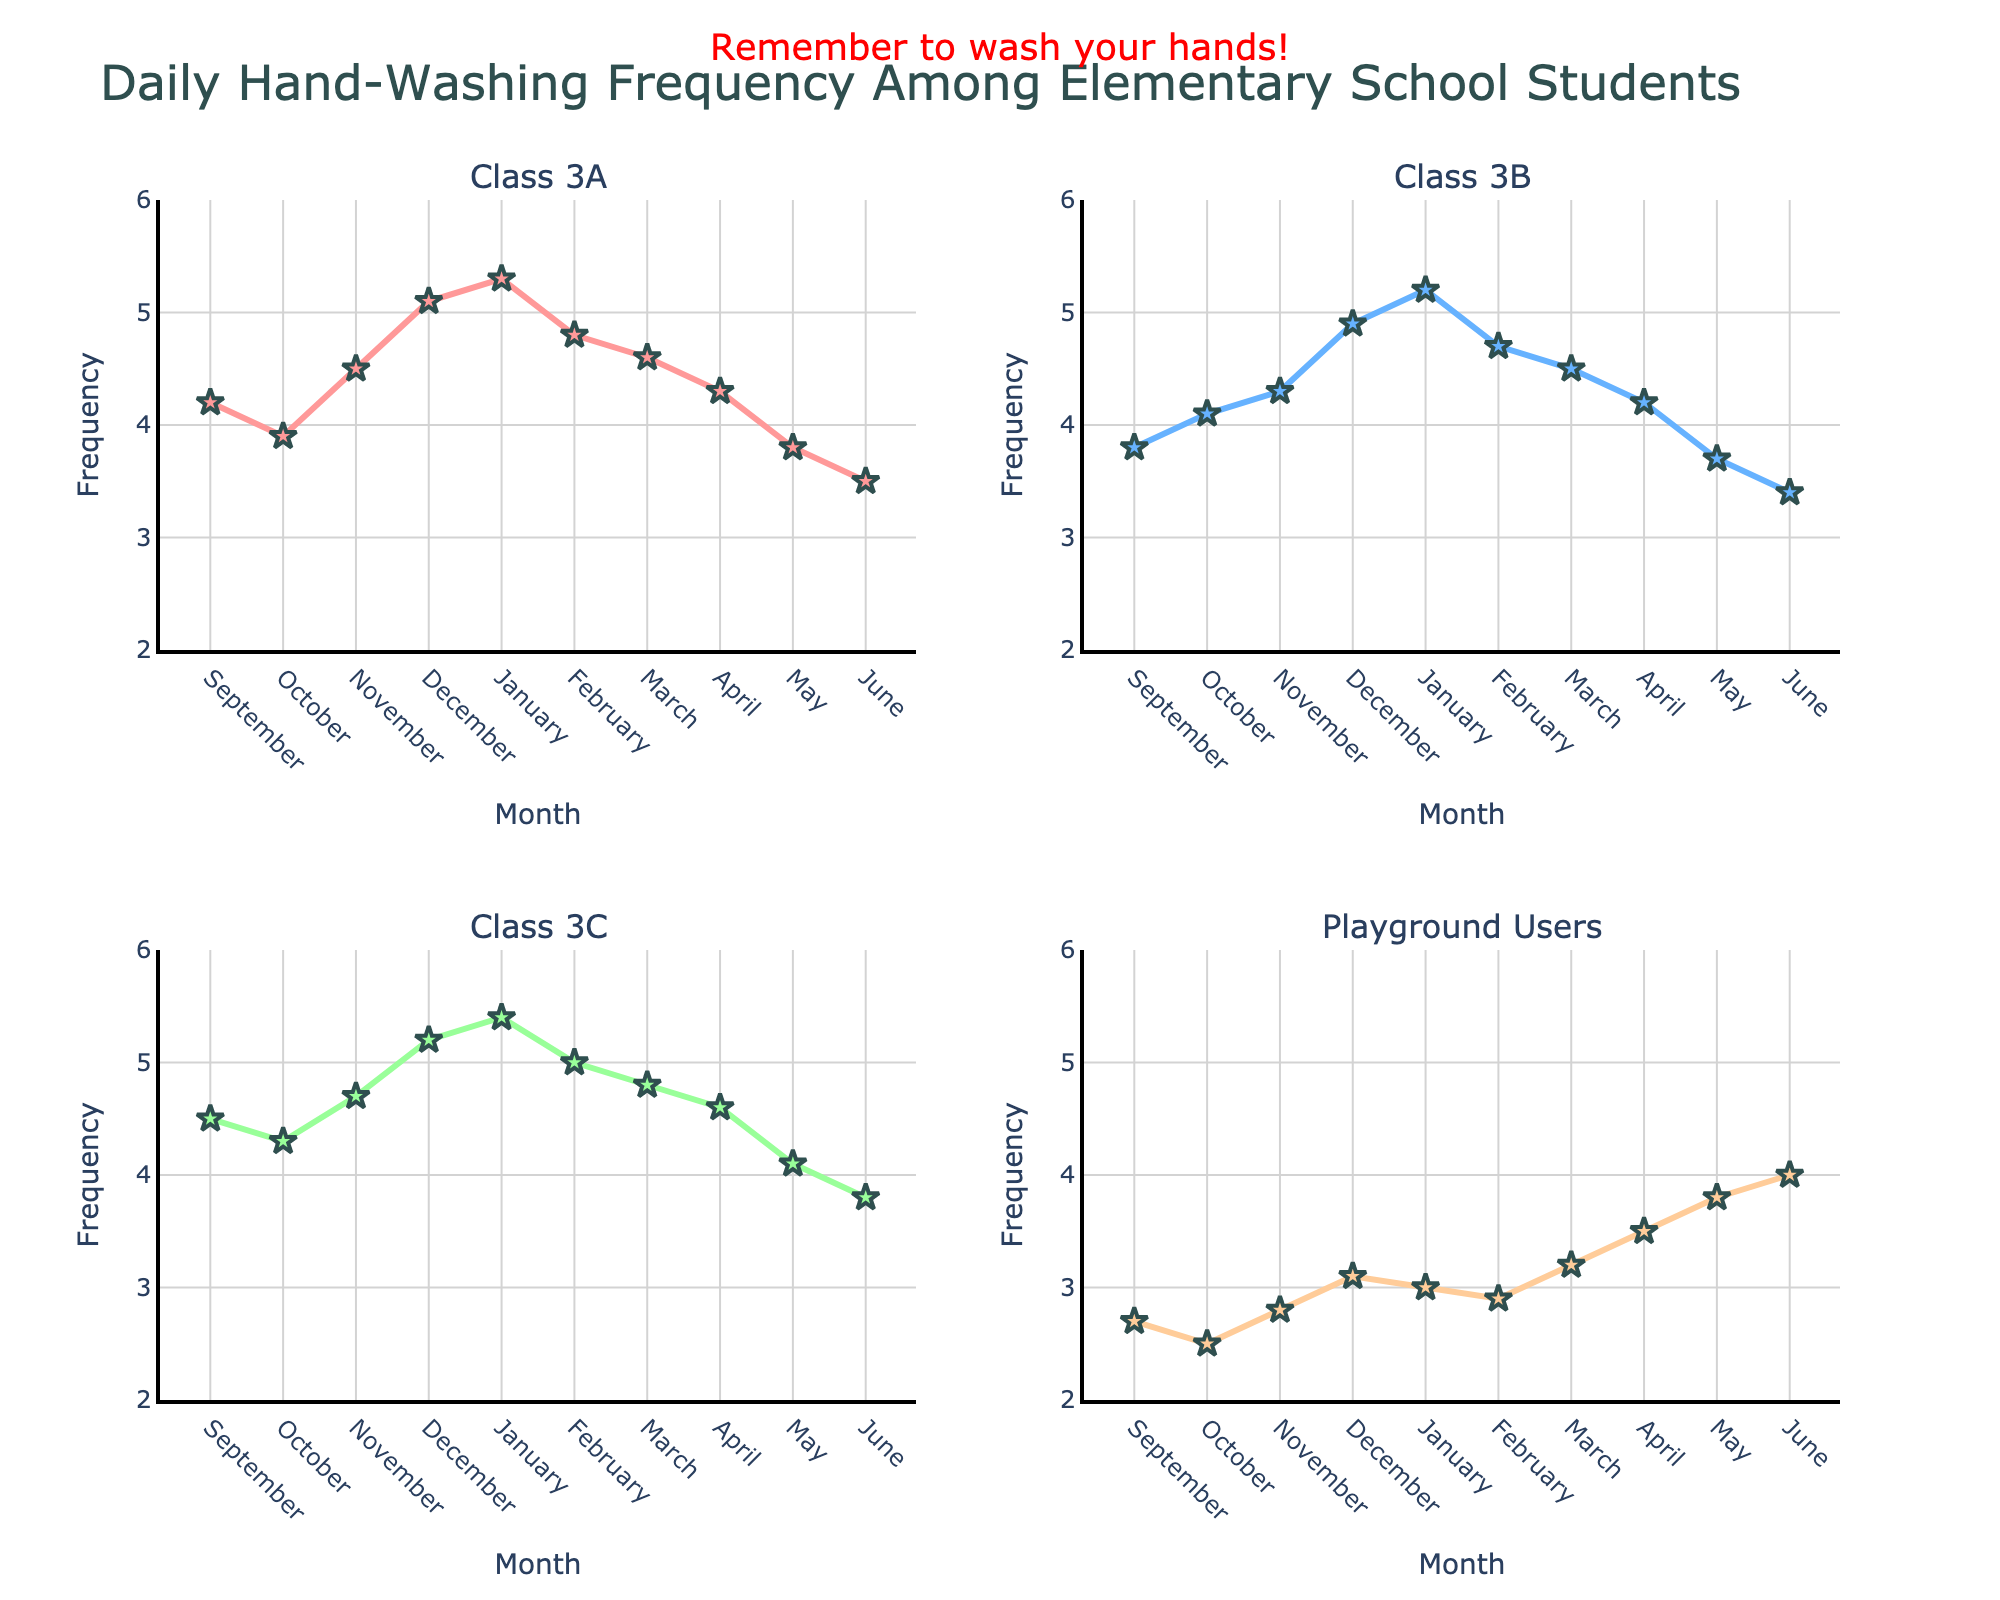What's the title of the figure? The title is usually at the top of the figure. The title here clearly states "Daily Hand-Washing Frequency Among Elementary School Students".
Answer: Daily Hand-Washing Frequency Among Elementary School Students Which class had the highest hand-washing frequency in December? By looking at the December data points on each subplot (Class 3A, Class 3B, Class 3C, and Playground Users), we see that Class 3C has the highest point.
Answer: Class 3C What is the hand-washing frequency for Class 3B in May? On the subplot for Class 3B, find the data point for May, which corresponds to 3.7.
Answer: 3.7 How does the hand-washing frequency of Class 3A in February compare to that in January? In the subplot for Class 3A, the frequency in February is 4.8, while in January it is 5.3. January's frequency is higher.
Answer: January is higher Which class shows the greatest increase in hand-washing frequency from September to December? Calculate the difference from September to December for each class:
Class 3A: 5.1 - 4.2 = 0.9
Class 3B: 4.9 - 3.8 = 1.1
Class 3C: 5.2 - 4.5 = 0.7
Class 3B shows the greatest increase.
Answer: Class 3B What is the average hand-washing frequency for Playground Users in the first quarter (September, October, November)? Sum the frequencies for Playground Users in September (2.7), October (2.5), and November (2.8), then divide by 3: (2.7 + 2.5 + 2.8) / 3 = 2.67.
Answer: 2.67 Which class had the most consistent hand-washing frequency throughout the year, judging by the line smoothness? Smoothness implies consistency. Observing the lines, Class 3B's line is the smoothest, with fewer abrupt changes.
Answer: Class 3B By how much does the hand-washing frequency for the Playground Users change from January to June? In the subplot for Playground Users, the frequency in January is 3.0 and in June is 4.0. The change is 4.0 - 3.0 = 1.0.
Answer: 1.0 In which month did Class 3A see the lowest hand-washing frequency? Checking all data points on the Class 3A subplot, the lowest frequency occurs in June at 3.5.
Answer: June What is the average hand-washing frequency for Class 3C from January to March? Sum the frequencies for Class 3C in January (5.4), February (5.0), and March (4.8), then divide by 3: (5.4 + 5.0 + 4.8) / 3 = 5.07.
Answer: 5.07 